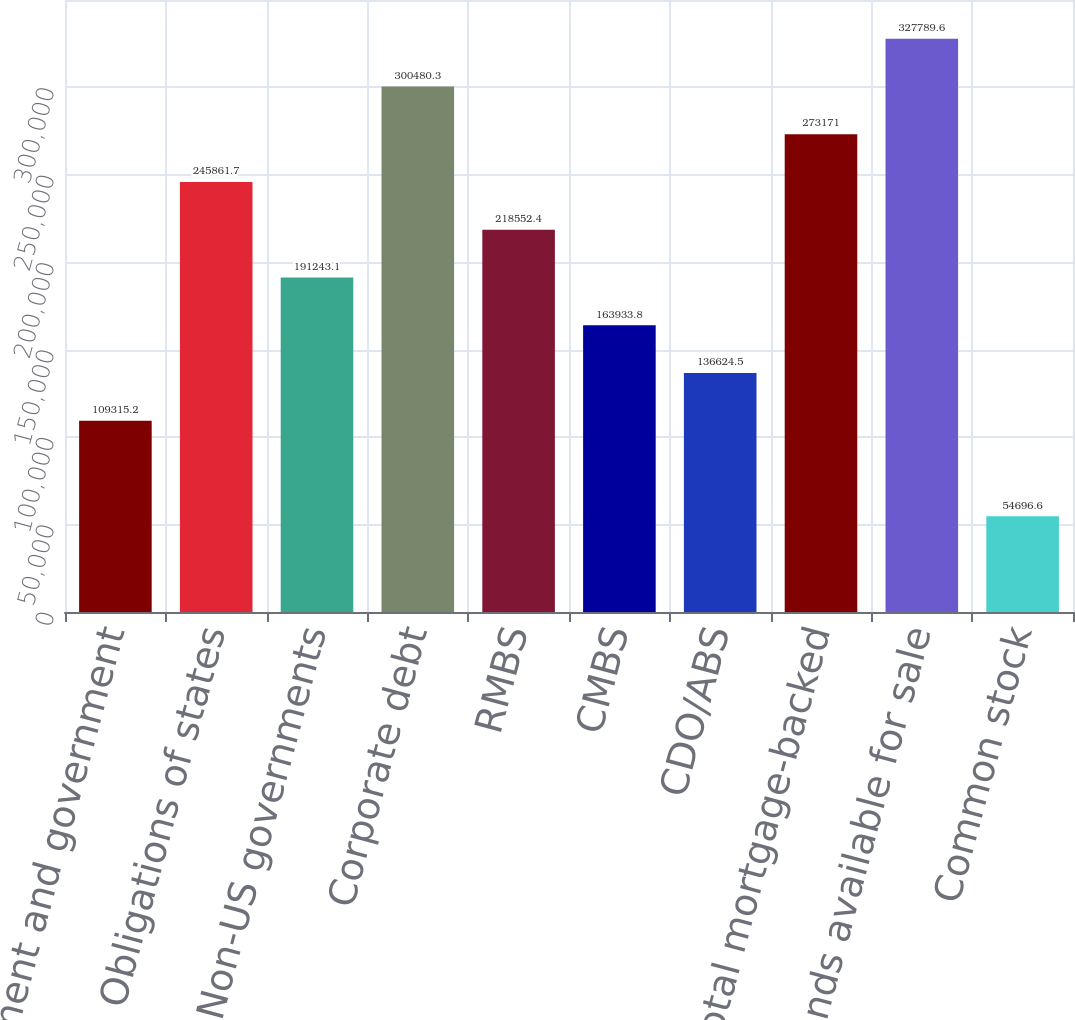<chart> <loc_0><loc_0><loc_500><loc_500><bar_chart><fcel>US government and government<fcel>Obligations of states<fcel>Non-US governments<fcel>Corporate debt<fcel>RMBS<fcel>CMBS<fcel>CDO/ABS<fcel>Total mortgage-backed<fcel>Total bonds available for sale<fcel>Common stock<nl><fcel>109315<fcel>245862<fcel>191243<fcel>300480<fcel>218552<fcel>163934<fcel>136624<fcel>273171<fcel>327790<fcel>54696.6<nl></chart> 